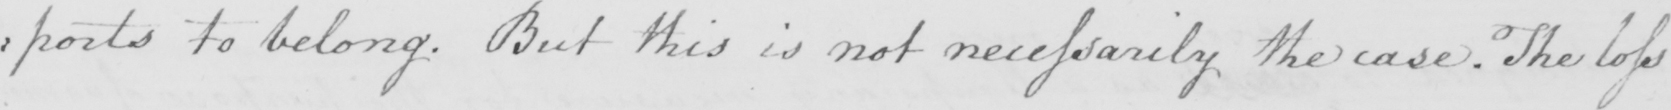Please transcribe the handwritten text in this image. : ports to belong . but this is not necessarily the case . The loss 